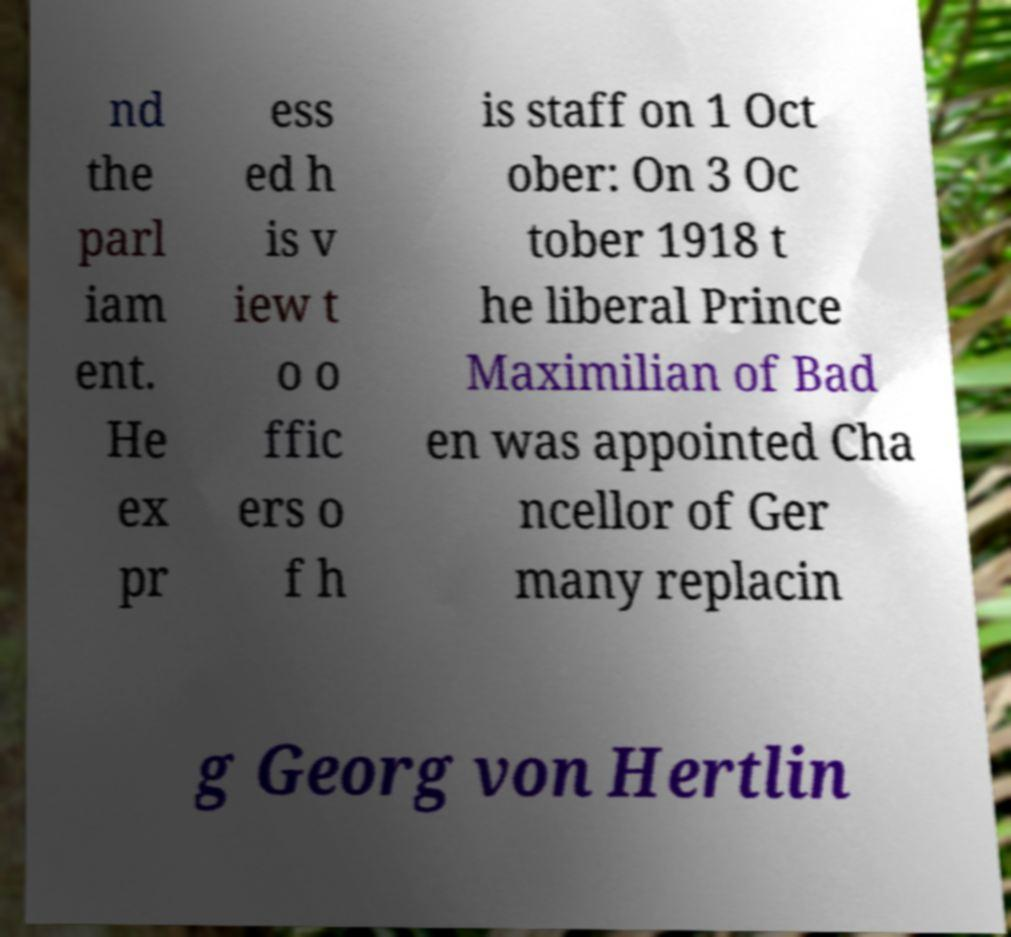Please read and relay the text visible in this image. What does it say? nd the parl iam ent. He ex pr ess ed h is v iew t o o ffic ers o f h is staff on 1 Oct ober: On 3 Oc tober 1918 t he liberal Prince Maximilian of Bad en was appointed Cha ncellor of Ger many replacin g Georg von Hertlin 